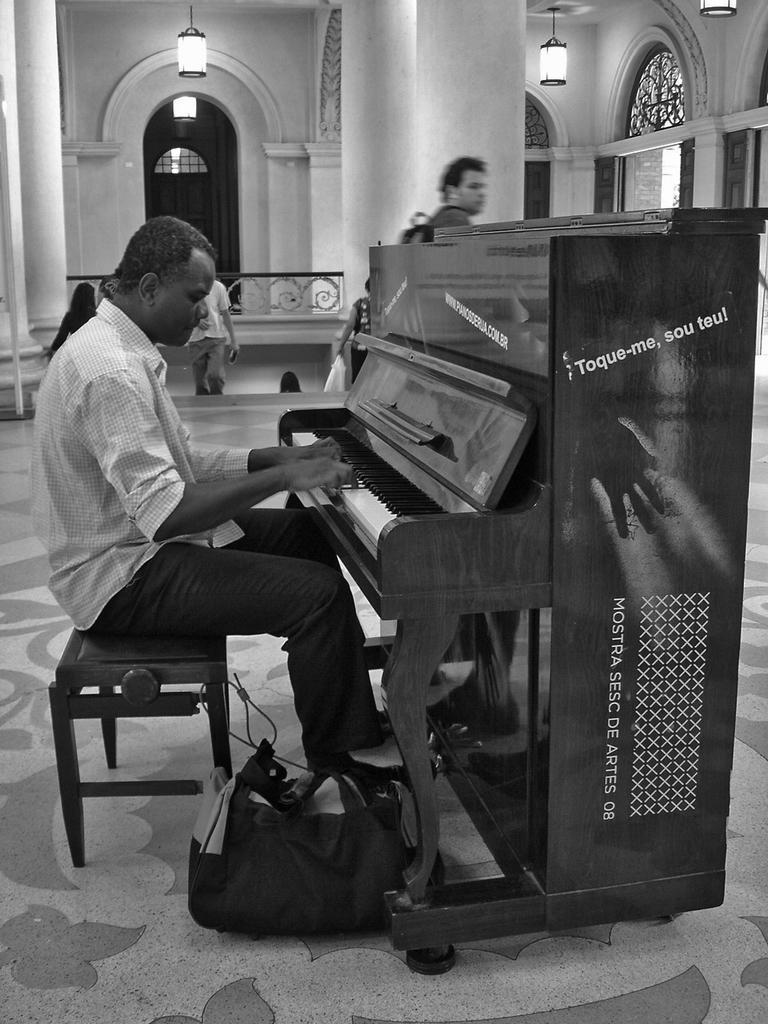In one or two sentences, can you explain what this image depicts? This picture shows a man playing a piano and we see a man walking 